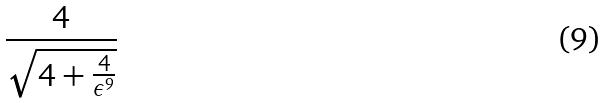Convert formula to latex. <formula><loc_0><loc_0><loc_500><loc_500>\frac { 4 } { \sqrt { 4 + \frac { 4 } { \epsilon ^ { 9 } } } }</formula> 